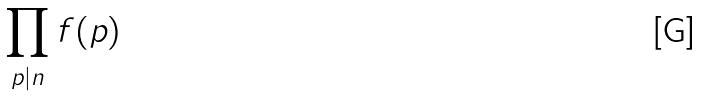Convert formula to latex. <formula><loc_0><loc_0><loc_500><loc_500>\prod _ { p | n } f ( p )</formula> 